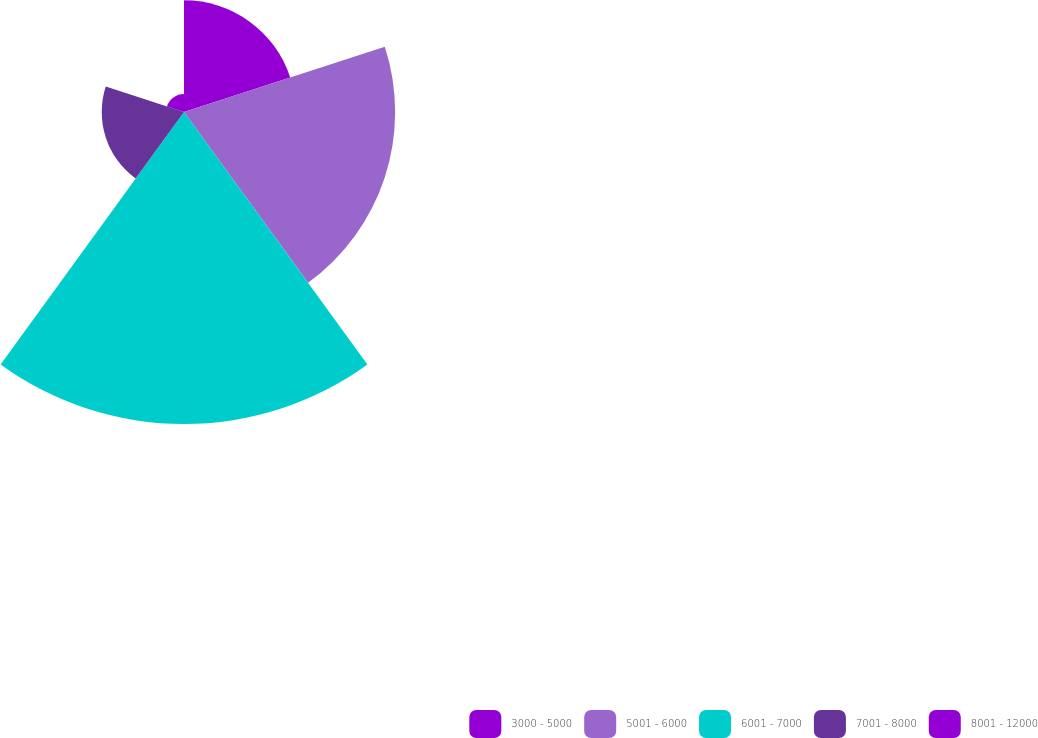<chart> <loc_0><loc_0><loc_500><loc_500><pie_chart><fcel>3000 - 5000<fcel>5001 - 6000<fcel>6001 - 7000<fcel>7001 - 8000<fcel>8001 - 12000<nl><fcel>15.19%<fcel>28.72%<fcel>42.44%<fcel>11.19%<fcel>2.45%<nl></chart> 